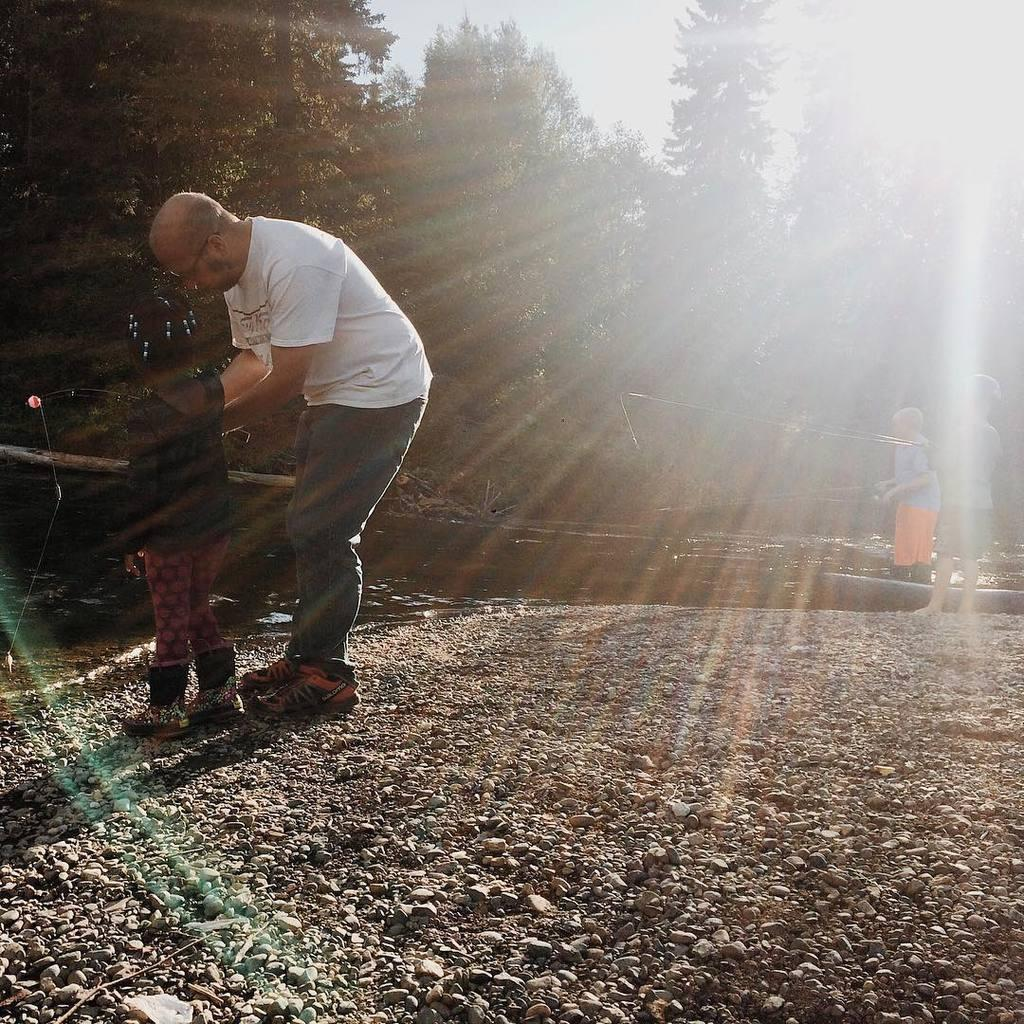What are the people in the image doing? The people in the image are standing and holding sticks. What can be seen in the background of the image? There are trees in the image. What is the weather like in the image? The sun is observable in the sky in the image, suggesting a sunny day. Is there any water visible in the image? Yes, there is water visible in the image. What type of honey can be seen dripping from the trees in the image? There is no honey present in the image; it features people holding sticks and trees in the background. 